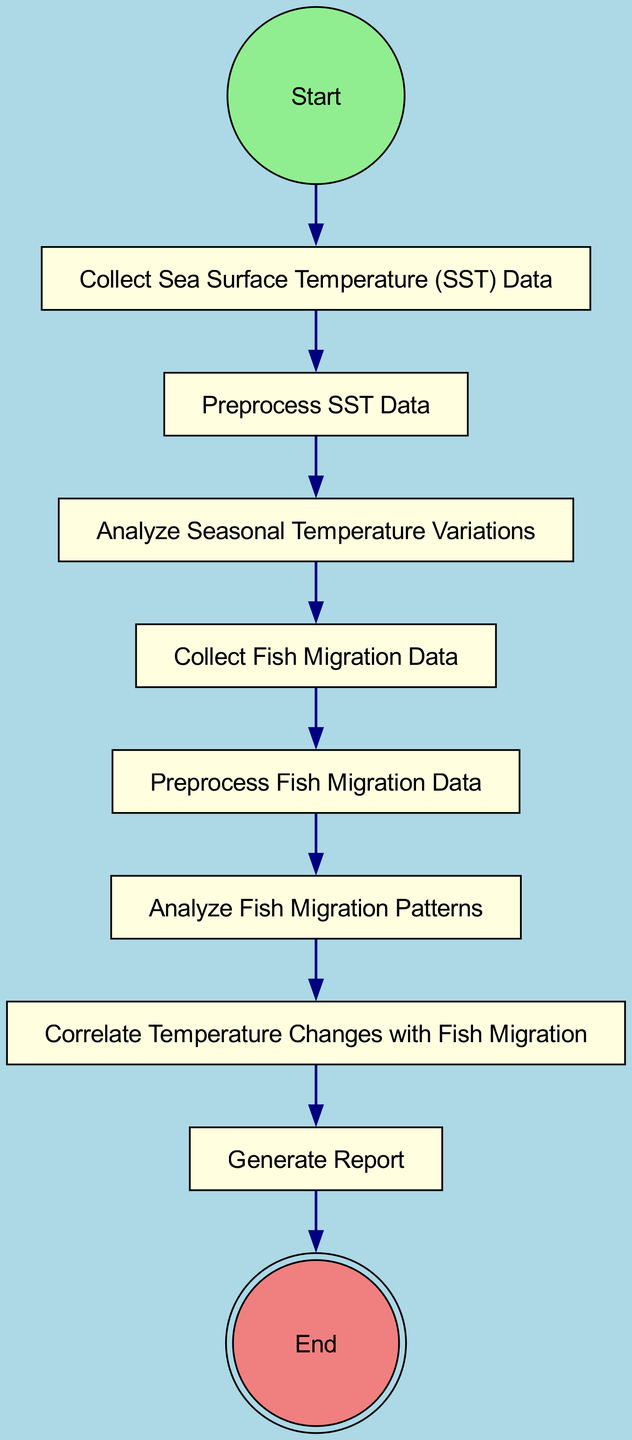What is the first activity in the sequence? The diagram begins with the "Start" node, which points to the next action, "Collect Sea Surface Temperature (SST) Data." Therefore, the first activity is the one immediately following the start node.
Answer: Collect Sea Surface Temperature (SST) Data How many activities are there in the diagram? By counting the individual activities listed in the diagram, there are eight distinct activities specified in the sequence.
Answer: Eight What comes after "Analyze Seasonal Temperature Variations"? The diagram indicates that the next activity in the sequence after "Analyze Seasonal Temperature Variations" is "Collect Fish Migration Data." This is established by following the directed edge originating from the former activity.
Answer: Collect Fish Migration Data What is the final action in the sequence? According to the flow of the diagram, the last action before reaching the "End" node is "Generate Report," which is the concluding step in the process.
Answer: Generate Report How does "Correlate Temperature Changes with Fish Migration" relate to "Analyze Fish Migration Patterns"? The diagram shows a direct connection with a sequential edge from "Analyze Fish Migration Patterns" to "Correlate Temperature Changes with Fish Migration," signifying that the correlation follows the analysis of fish migration patterns.
Answer: Sequential connection What type of diagram is being described? The diagram represents an Activity Diagram, which is designed to illustrate a sequence of actions or activities in a process along with their relationships.
Answer: Activity Diagram Which action does "Preprocess SST Data" lead to? According to the diagram, the action "Preprocess SST Data" leads directly to "Analyze Seasonal Temperature Variations," establishing a clear pathway from one step to the next.
Answer: Analyze Seasonal Temperature Variations Which activities involve data collection? The activities that involve data collection are "Collect Sea Surface Temperature (SST) Data" and "Collect Fish Migration Data," both of which are explicitly mentioned in the diagram as initial steps.
Answer: Collect Sea Surface Temperature (SST) Data, Collect Fish Migration Data 